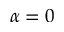Convert formula to latex. <formula><loc_0><loc_0><loc_500><loc_500>\alpha = 0</formula> 